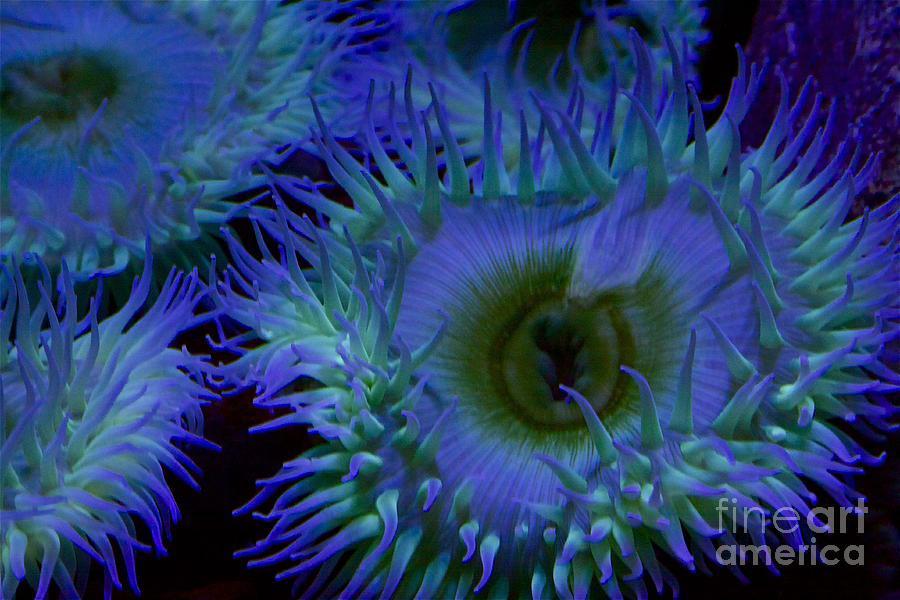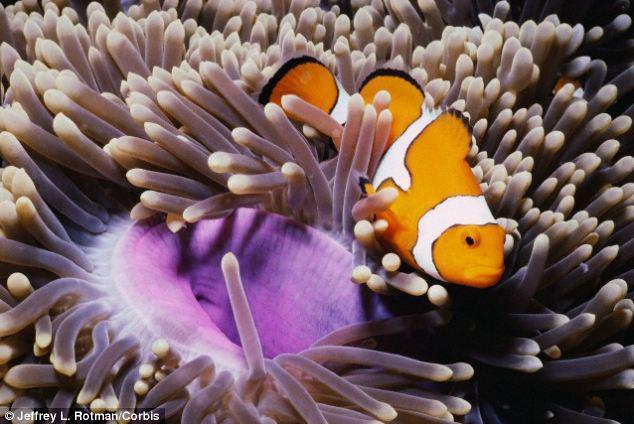The first image is the image on the left, the second image is the image on the right. Examine the images to the left and right. Is the description "fish are swimming near anemones" accurate? Answer yes or no. Yes. The first image is the image on the left, the second image is the image on the right. Analyze the images presented: Is the assertion "White striped fish swim among anemones." valid? Answer yes or no. Yes. 